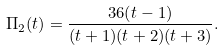<formula> <loc_0><loc_0><loc_500><loc_500>\Pi _ { 2 } ( t ) = \frac { 3 6 ( t - 1 ) } { ( t + 1 ) ( t + 2 ) ( t + 3 ) } .</formula> 